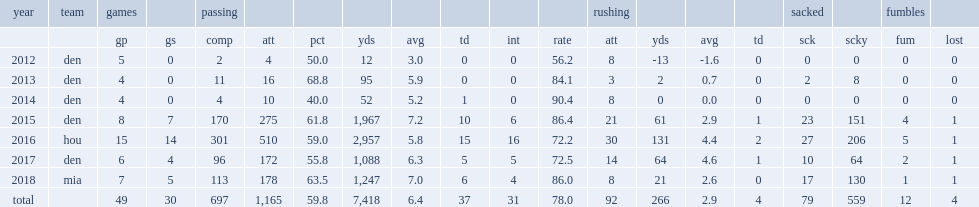How many passing yards did brock osweiler get in 2018? 1247.0. Can you parse all the data within this table? {'header': ['year', 'team', 'games', '', 'passing', '', '', '', '', '', '', '', 'rushing', '', '', '', 'sacked', '', 'fumbles', ''], 'rows': [['', '', 'gp', 'gs', 'comp', 'att', 'pct', 'yds', 'avg', 'td', 'int', 'rate', 'att', 'yds', 'avg', 'td', 'sck', 'scky', 'fum', 'lost'], ['2012', 'den', '5', '0', '2', '4', '50.0', '12', '3.0', '0', '0', '56.2', '8', '-13', '-1.6', '0', '0', '0', '0', '0'], ['2013', 'den', '4', '0', '11', '16', '68.8', '95', '5.9', '0', '0', '84.1', '3', '2', '0.7', '0', '2', '8', '0', '0'], ['2014', 'den', '4', '0', '4', '10', '40.0', '52', '5.2', '1', '0', '90.4', '8', '0', '0.0', '0', '0', '0', '0', '0'], ['2015', 'den', '8', '7', '170', '275', '61.8', '1,967', '7.2', '10', '6', '86.4', '21', '61', '2.9', '1', '23', '151', '4', '1'], ['2016', 'hou', '15', '14', '301', '510', '59.0', '2,957', '5.8', '15', '16', '72.2', '30', '131', '4.4', '2', '27', '206', '5', '1'], ['2017', 'den', '6', '4', '96', '172', '55.8', '1,088', '6.3', '5', '5', '72.5', '14', '64', '4.6', '1', '10', '64', '2', '1'], ['2018', 'mia', '7', '5', '113', '178', '63.5', '1,247', '7.0', '6', '4', '86.0', '8', '21', '2.6', '0', '17', '130', '1', '1'], ['total', '', '49', '30', '697', '1,165', '59.8', '7,418', '6.4', '37', '31', '78.0', '92', '266', '2.9', '4', '79', '559', '12', '4']]} 